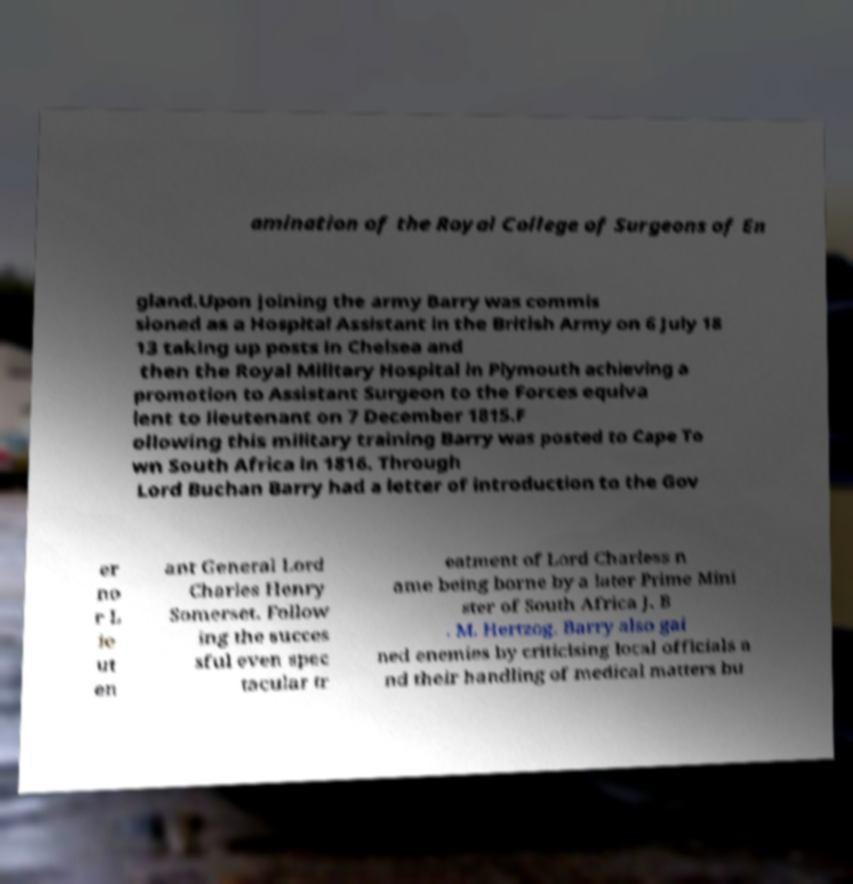Could you assist in decoding the text presented in this image and type it out clearly? amination of the Royal College of Surgeons of En gland.Upon joining the army Barry was commis sioned as a Hospital Assistant in the British Army on 6 July 18 13 taking up posts in Chelsea and then the Royal Military Hospital in Plymouth achieving a promotion to Assistant Surgeon to the Forces equiva lent to lieutenant on 7 December 1815.F ollowing this military training Barry was posted to Cape To wn South Africa in 1816. Through Lord Buchan Barry had a letter of introduction to the Gov er no r L ie ut en ant General Lord Charles Henry Somerset. Follow ing the succes sful even spec tacular tr eatment of Lord Charless n ame being borne by a later Prime Mini ster of South Africa J. B . M. Hertzog. Barry also gai ned enemies by criticising local officials a nd their handling of medical matters bu 